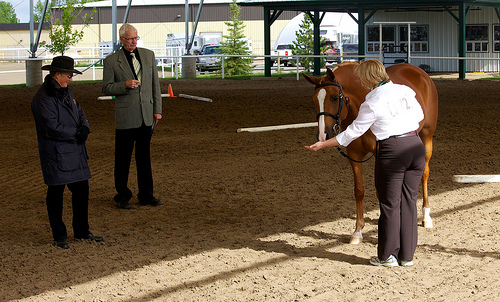<image>
Is there a white truck to the left of the black pants? No. The white truck is not to the left of the black pants. From this viewpoint, they have a different horizontal relationship. 